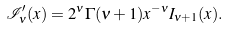<formula> <loc_0><loc_0><loc_500><loc_500>\mathcal { I } _ { \nu } ^ { \prime } ( x ) = 2 ^ { \nu } \Gamma ( \nu + 1 ) x ^ { - \nu } I _ { \nu + 1 } ( x ) .</formula> 